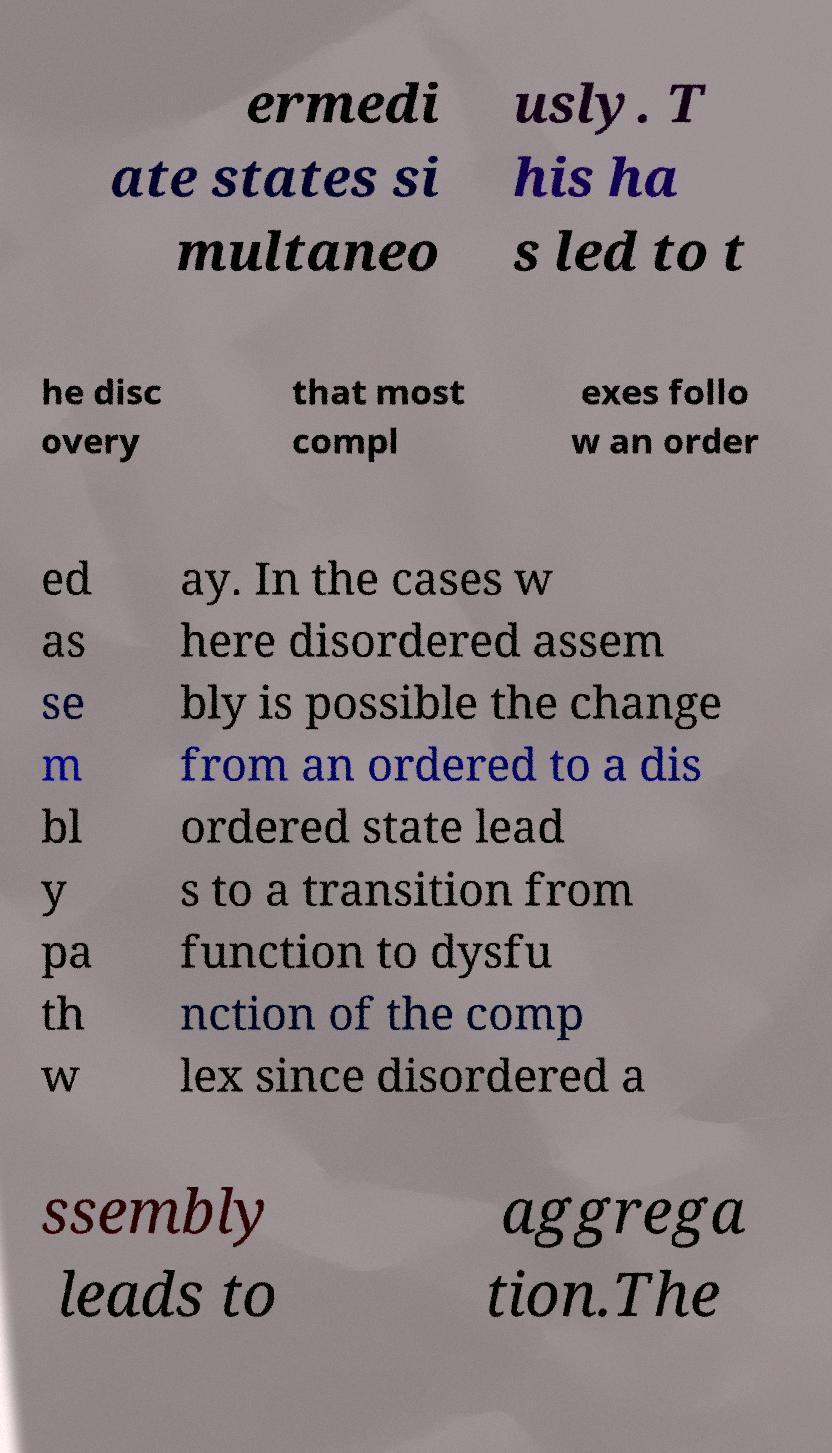Could you assist in decoding the text presented in this image and type it out clearly? ermedi ate states si multaneo usly. T his ha s led to t he disc overy that most compl exes follo w an order ed as se m bl y pa th w ay. In the cases w here disordered assem bly is possible the change from an ordered to a dis ordered state lead s to a transition from function to dysfu nction of the comp lex since disordered a ssembly leads to aggrega tion.The 